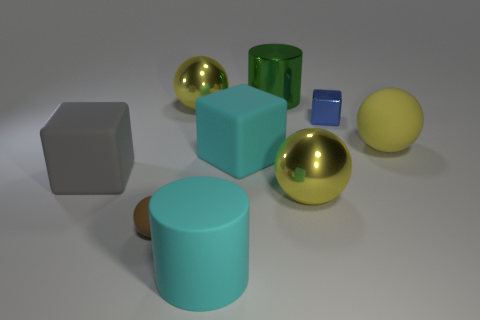Is the metal cylinder the same color as the tiny shiny object?
Keep it short and to the point. No. Is there anything else that is the same size as the blue shiny object?
Your answer should be compact. Yes. Does the yellow matte object have the same shape as the yellow shiny object in front of the yellow rubber thing?
Provide a succinct answer. Yes. What is the color of the large cube to the left of the rubber ball left of the shiny sphere that is in front of the yellow matte sphere?
Your answer should be very brief. Gray. What number of objects are shiny spheres in front of the large gray matte object or yellow rubber balls behind the cyan rubber cube?
Your answer should be very brief. 2. How many other objects are the same color as the small metallic block?
Your response must be concise. 0. Does the big metal object in front of the big yellow matte ball have the same shape as the small shiny object?
Keep it short and to the point. No. Are there fewer tiny brown matte balls to the right of the large cyan cylinder than big blue metallic spheres?
Ensure brevity in your answer.  No. Is there a tiny gray thing that has the same material as the big green cylinder?
Your response must be concise. No. What material is the green thing that is the same size as the matte cylinder?
Make the answer very short. Metal. 